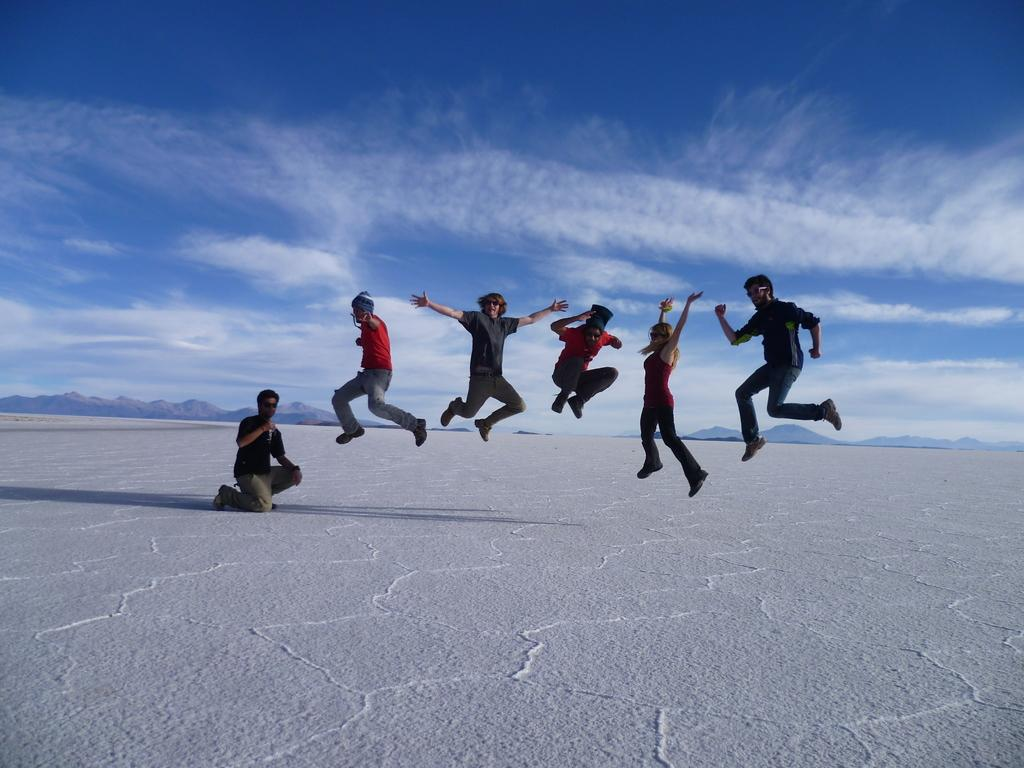How many people are in the image? There are multiple persons in the image. What are the persons in the image doing? The persons are jumping. Can you describe the gender of the people in the image? There are men in the image, and at least one woman is present. What is visible at the top of the image? The sky is visible at the top of the image. What type of mountain can be seen in the background of the image? There is no mountain visible in the image; it only shows multiple persons jumping. How does the dirt affect the competition in the image? There is no competition or dirt present in the image. 